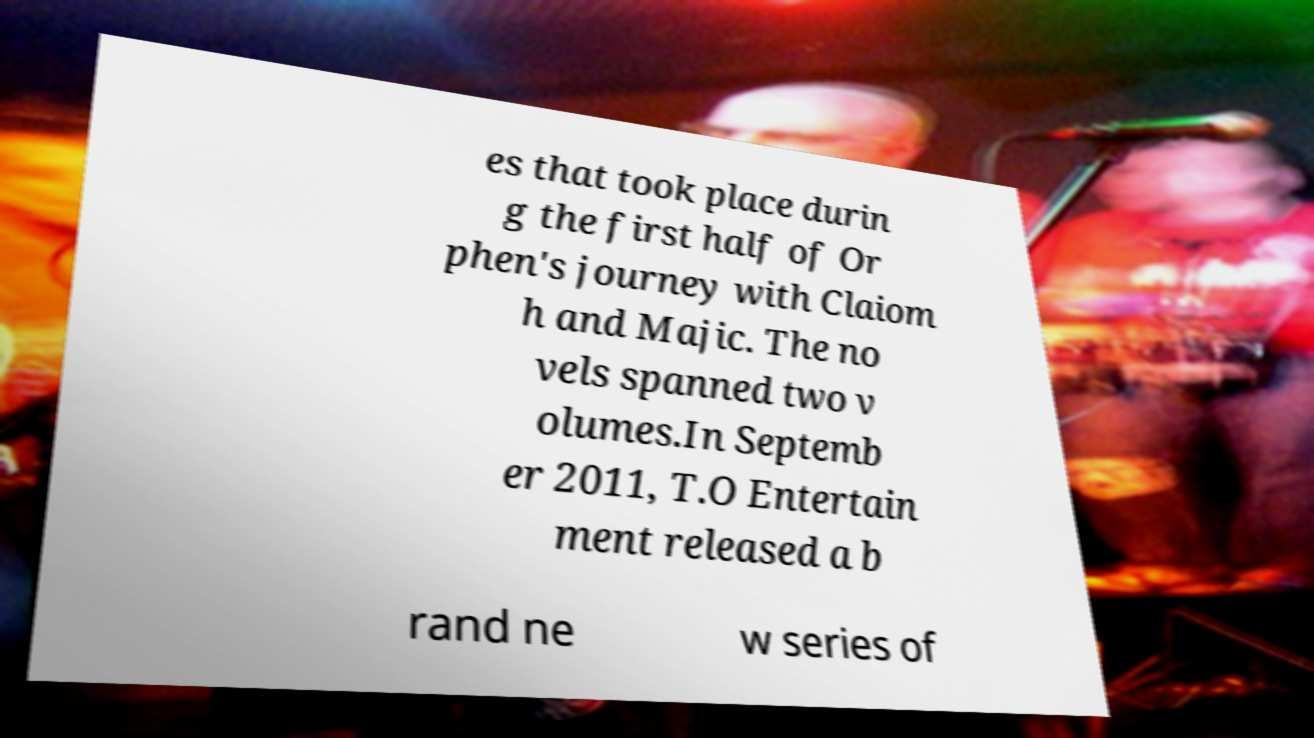I need the written content from this picture converted into text. Can you do that? es that took place durin g the first half of Or phen's journey with Claiom h and Majic. The no vels spanned two v olumes.In Septemb er 2011, T.O Entertain ment released a b rand ne w series of 